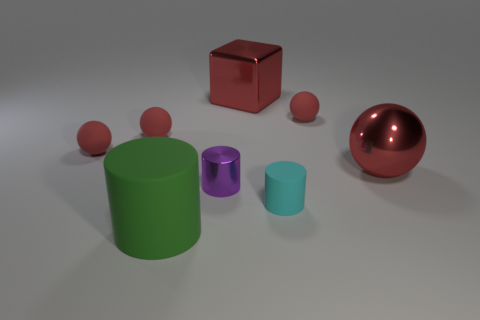How many red balls must be subtracted to get 2 red balls? 2 Subtract 1 balls. How many balls are left? 3 Add 1 big things. How many objects exist? 9 Subtract all cubes. How many objects are left? 7 Subtract all big red balls. Subtract all large matte cylinders. How many objects are left? 6 Add 7 large matte cylinders. How many large matte cylinders are left? 8 Add 3 small rubber cylinders. How many small rubber cylinders exist? 4 Subtract 0 yellow cylinders. How many objects are left? 8 